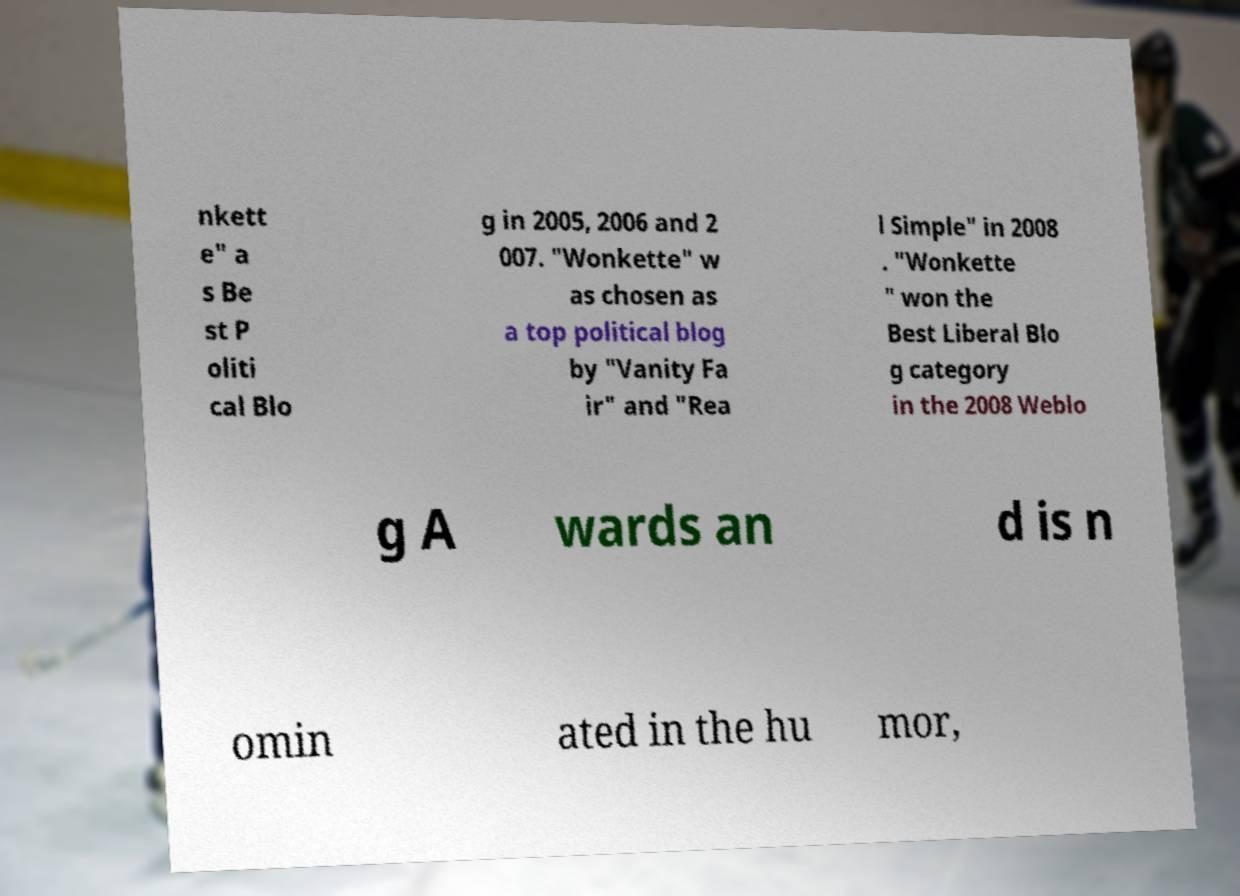For documentation purposes, I need the text within this image transcribed. Could you provide that? nkett e" a s Be st P oliti cal Blo g in 2005, 2006 and 2 007. "Wonkette" w as chosen as a top political blog by "Vanity Fa ir" and "Rea l Simple" in 2008 . "Wonkette " won the Best Liberal Blo g category in the 2008 Weblo g A wards an d is n omin ated in the hu mor, 